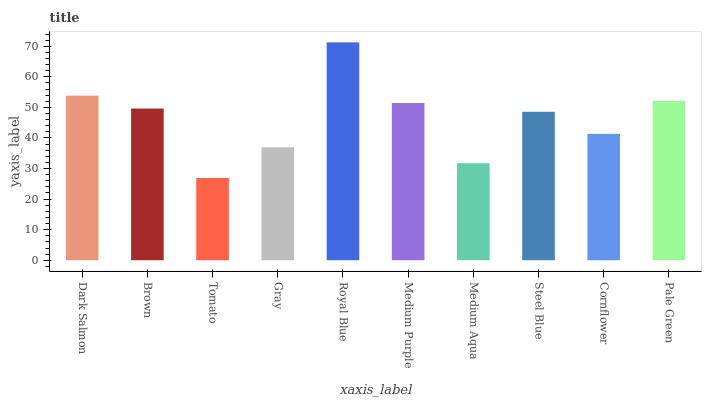Is Tomato the minimum?
Answer yes or no. Yes. Is Royal Blue the maximum?
Answer yes or no. Yes. Is Brown the minimum?
Answer yes or no. No. Is Brown the maximum?
Answer yes or no. No. Is Dark Salmon greater than Brown?
Answer yes or no. Yes. Is Brown less than Dark Salmon?
Answer yes or no. Yes. Is Brown greater than Dark Salmon?
Answer yes or no. No. Is Dark Salmon less than Brown?
Answer yes or no. No. Is Brown the high median?
Answer yes or no. Yes. Is Steel Blue the low median?
Answer yes or no. Yes. Is Medium Purple the high median?
Answer yes or no. No. Is Pale Green the low median?
Answer yes or no. No. 